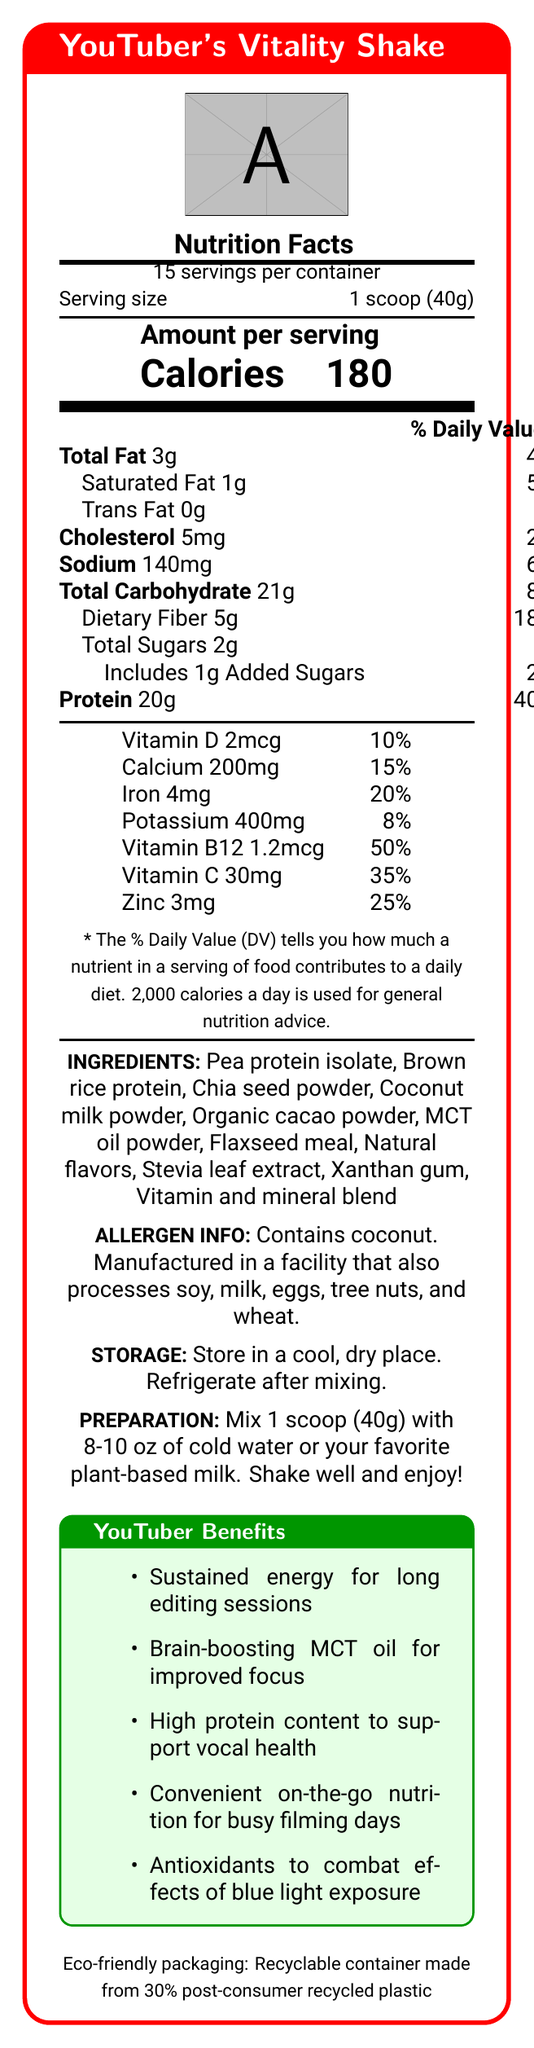what is the serving size? The serving size is stated clearly under "Serving size" in the Nutrition Facts section.
Answer: 1 scoop (40g) how many servings are in each container? The number of servings per container is mentioned right below the product's name.
Answer: 15 servings how many calories are in each serving? The amount of calories per serving is indicated in the "Calories" section.
Answer: 180 what percentage of the daily value of protein does each serving provide? The protein section states that 20g constitutes 40% of the daily value.
Answer: 40% is there any trans fat in the shake? The document specifies "Trans Fat 0g" under the Total Fat section.
Answer: No does the product contain any allergens? The allergen information states that the product contains coconut.
Answer: Yes how should the shake be prepared? A. Mix with hot water B. Mix with cold water or plant-based milk C. Blend with ice cream D. Consume directly from the container The preparation instructions specify mixing 1 scoop with 8-10 oz of cold water or plant-based milk.
Answer: B how much sodium is in each serving? The sodium content per serving is listed under the Total Carbohydrate section.
Answer: 140mg which ingredient is not in the YouTuber's Vitality Shake? A. Pea protein isolate B. Soy protein C. Chia seed powder D. Flaxseed meal The ingredients list does not mention soy protein.
Answer: B does the packaging of this shake have any eco-friendly features? The packaging is described as being made from 30% post-consumer recycled plastic.
Answer: Yes what is the main idea of this document? The document outlines the nutritional content, benefits, and usage instructions for a meal replacement shake designed for YouTubers.
Answer: The document provides detailed nutritional information about the YouTuber's Vitality Shake, including ingredients, allergens, preparation instructions, and YouTuber-specific benefits. which vitamin has the highest daily value percentage in this shake? The daily value for Vitamin B12 is 50%, which is the highest among the vitamins and minerals listed.
Answer: Vitamin B12 what is the purpose of MCT oil in the shake? MCT oil is mentioned in the YouTube-specific benefits section as aiding in brain function and focus.
Answer: Brain-boosting for improved focus what type of nutrition does the shake provide for long editing sessions? The YouTube-specific benefits section lists sustained energy as one of the features of the shake.
Answer: Sustained energy how much dietary fiber is in each serving? The amount of dietary fiber is listed under the Total Carbohydrate section.
Answer: 5g does each serving contain any added sugars? The document states that each serving includes 1g of added sugars.
Answer: Yes what is the total carbohydrate content per serving? The document lists the total carbohydrate content under the Total Carbohydrate section.
Answer: 21g what kind of vitamins does the shake contain? A. Only Vitamin D and Vitamin C B. Only Vitamin B12 and Vitamin D C. Vitamin D, Calcium, Iron, Potassium, Vitamin B12, Vitamin C, Zinc The document specifies all these vitamins and minerals in the nutrition facts.
Answer: C does each serving contain iron? The nutrition facts list 4mg of iron.
Answer: Yes what type of focus enhancement does the shake offer specifically for YouTubers? The YouTube-specific benefits section mentions the brain-boosting properties of MCT oil for improved focus.
Answer: Brain-boosting MCT oil how much potassium is in each serving? The potassium content of each serving is listed under the vitamins and minerals section.
Answer: 400mg is the shake suitable for someone with soy allergies? The document states that the product is manufactured in a facility that processes soy, but does not specify whether it is completely free from soy contamination.
Answer: Cannot be determined is the storage information of the shake provided? The storage instructions are given, advising to store in a cool, dry place and refrigerate after mixing.
Answer: Yes how many grams of saturated fat are there per serving? The amount of saturated fat per serving is listed under the Total Fat section.
Answer: 1g 